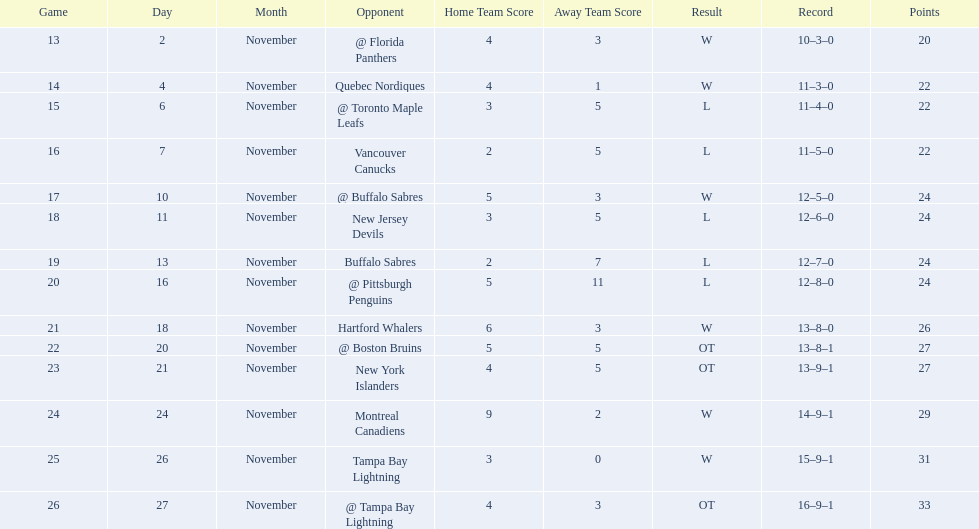What other team had the closest amount of wins? New York Islanders. 